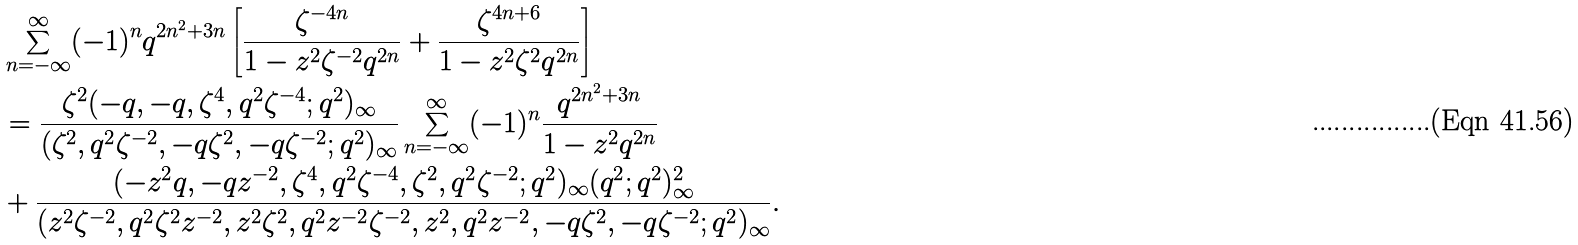Convert formula to latex. <formula><loc_0><loc_0><loc_500><loc_500>& \sum _ { n = - \infty } ^ { \infty } ( - 1 ) ^ { n } q ^ { 2 n ^ { 2 } + 3 n } \left [ \frac { \zeta ^ { - 4 n } } { 1 - z ^ { 2 } { \zeta ^ { - 2 } } q ^ { 2 n } } + \frac { \zeta ^ { 4 n + 6 } } { 1 - z ^ { 2 } { \zeta ^ { 2 } } q ^ { 2 n } } \right ] \\ & = \frac { \zeta ^ { 2 } ( - q , - q , \zeta ^ { 4 } , q ^ { 2 } \zeta ^ { - 4 } ; q ^ { 2 } ) _ { \infty } } { ( \zeta ^ { 2 } , q ^ { 2 } \zeta ^ { - 2 } , - q \zeta ^ { 2 } , - q \zeta ^ { - 2 } ; q ^ { 2 } ) _ { \infty } } \sum _ { n = - \infty } ^ { \infty } ( - 1 ) ^ { n } \frac { q ^ { 2 n ^ { 2 } + 3 n } } { 1 - z ^ { 2 } q ^ { 2 n } } \\ & + \frac { ( - z ^ { 2 } q , - q z ^ { - 2 } , \zeta ^ { 4 } , q ^ { 2 } \zeta ^ { - 4 } , \zeta ^ { 2 } , q ^ { 2 } \zeta ^ { - 2 } ; q ^ { 2 } ) _ { \infty } ( q ^ { 2 } ; q ^ { 2 } ) _ { \infty } ^ { 2 } } { ( z ^ { 2 } \zeta ^ { - 2 } , q ^ { 2 } \zeta ^ { 2 } z ^ { - 2 } , z ^ { 2 } \zeta ^ { 2 } , q ^ { 2 } z ^ { - 2 } \zeta ^ { - 2 } , z ^ { 2 } , q ^ { 2 } z ^ { - 2 } , - q \zeta ^ { 2 } , - q \zeta ^ { - 2 } ; q ^ { 2 } ) _ { \infty } } .</formula> 